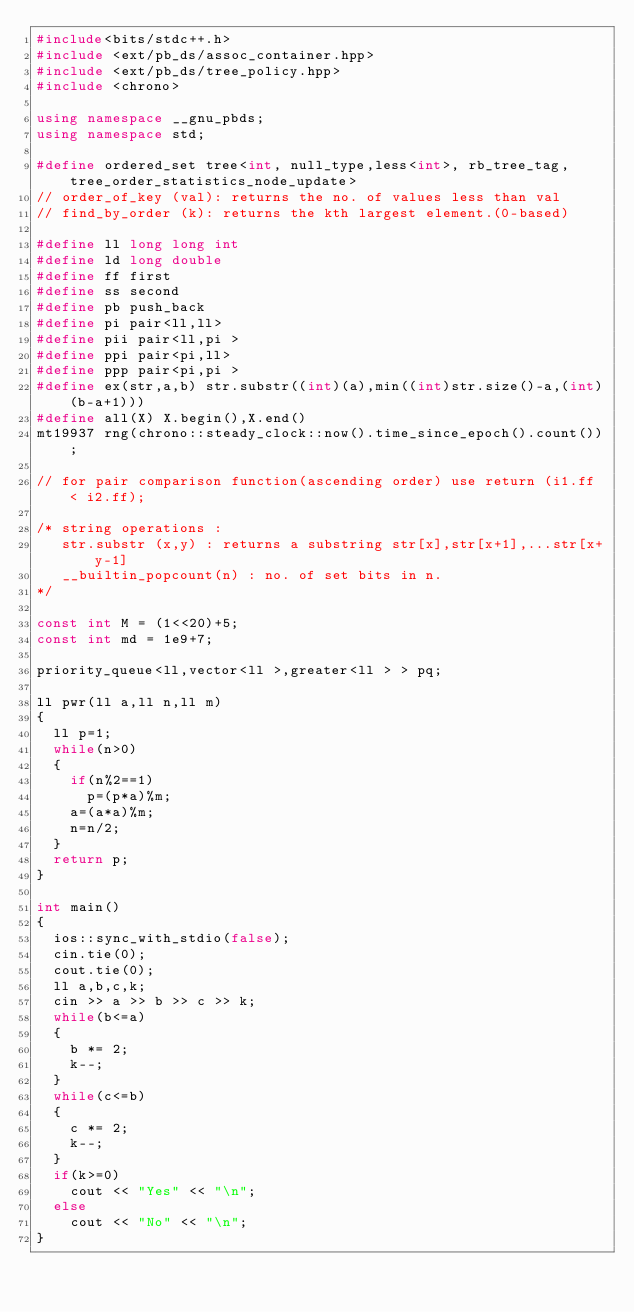<code> <loc_0><loc_0><loc_500><loc_500><_C++_>#include<bits/stdc++.h>
#include <ext/pb_ds/assoc_container.hpp>
#include <ext/pb_ds/tree_policy.hpp>
#include <chrono>

using namespace __gnu_pbds;
using namespace std;

#define ordered_set tree<int, null_type,less<int>, rb_tree_tag,tree_order_statistics_node_update>
// order_of_key (val): returns the no. of values less than val
// find_by_order (k): returns the kth largest element.(0-based)

#define ll long long int
#define ld long double
#define ff first
#define ss second
#define pb push_back
#define pi pair<ll,ll>
#define pii pair<ll,pi >
#define ppi pair<pi,ll>
#define ppp pair<pi,pi >
#define ex(str,a,b) str.substr((int)(a),min((int)str.size()-a,(int)(b-a+1))) 
#define all(X) X.begin(),X.end()
mt19937 rng(chrono::steady_clock::now().time_since_epoch().count());

// for pair comparison function(ascending order) use return (i1.ff < i2.ff);

/* string operations :
   str.substr (x,y) : returns a substring str[x],str[x+1],...str[x+y-1]
   __builtin_popcount(n) : no. of set bits in n.
*/

const int M = (1<<20)+5;
const int md = 1e9+7;

priority_queue<ll,vector<ll >,greater<ll > > pq;

ll pwr(ll a,ll n,ll m)
{
	ll p=1;
	while(n>0)
	{
		if(n%2==1)
			p=(p*a)%m;
		a=(a*a)%m;
		n=n/2;
	}
	return p;
}

int main()
{
	ios::sync_with_stdio(false);
	cin.tie(0);
	cout.tie(0);
	ll a,b,c,k;
	cin >> a >> b >> c >> k;
	while(b<=a)
	{
		b *= 2;
		k--;
	}
	while(c<=b)
	{
		c *= 2;
		k--;
	}
	if(k>=0)
		cout << "Yes" << "\n";
	else
		cout << "No" << "\n";
}</code> 